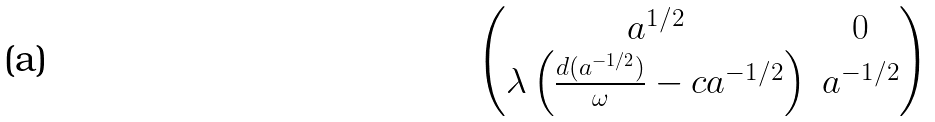Convert formula to latex. <formula><loc_0><loc_0><loc_500><loc_500>\begin{pmatrix} a ^ { 1 / 2 } & 0 \\ \lambda \left ( \frac { d ( a ^ { - 1 / 2 } ) } { \omega } - c a ^ { - 1 / 2 } \right ) & a ^ { - 1 / 2 } \end{pmatrix}</formula> 